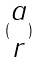<formula> <loc_0><loc_0><loc_500><loc_500>( \begin{matrix} a \\ r \end{matrix} )</formula> 